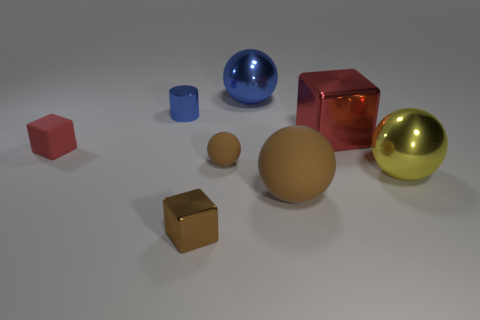Does the tiny sphere have the same color as the large matte ball?
Provide a succinct answer. Yes. How many other things are there of the same color as the small matte ball?
Make the answer very short. 2. How many objects are big gray shiny things or large yellow spheres?
Your answer should be compact. 1. Does the red rubber object have the same size as the metallic sphere that is in front of the red matte object?
Provide a short and direct response. No. How many other objects are the same material as the large brown thing?
Provide a succinct answer. 2. What number of things are either big objects that are behind the small ball or shiny things behind the red shiny block?
Give a very brief answer. 3. What is the material of the other small red thing that is the same shape as the red shiny object?
Ensure brevity in your answer.  Rubber. Are any brown objects visible?
Your response must be concise. Yes. There is a object that is both in front of the big yellow metallic ball and behind the small brown block; what size is it?
Ensure brevity in your answer.  Large. What shape is the large red object?
Your answer should be very brief. Cube. 